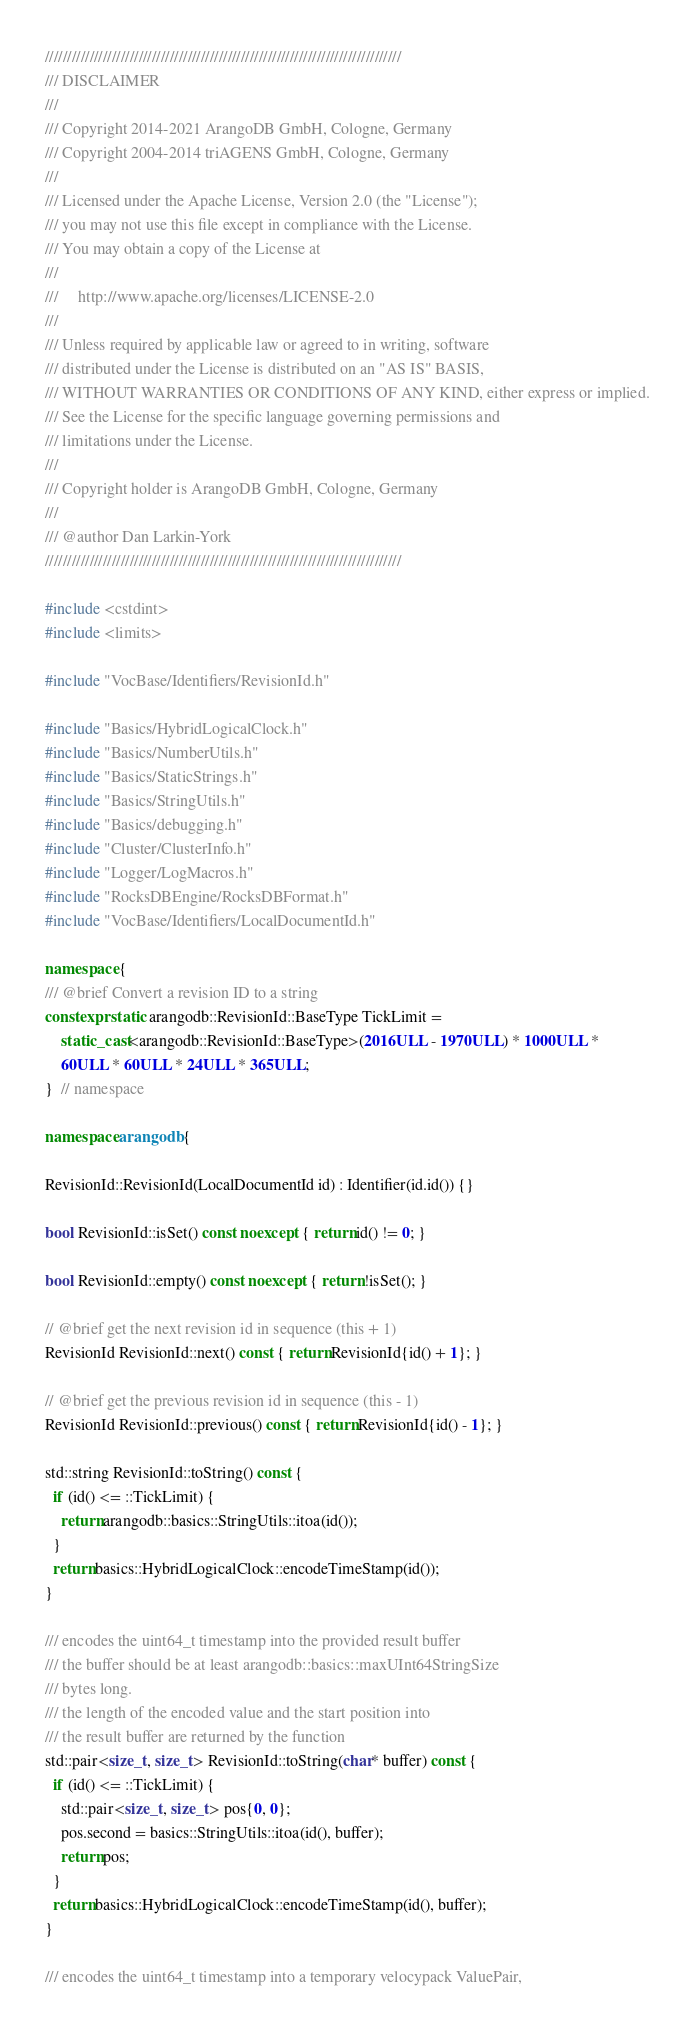<code> <loc_0><loc_0><loc_500><loc_500><_C++_>////////////////////////////////////////////////////////////////////////////////
/// DISCLAIMER
///
/// Copyright 2014-2021 ArangoDB GmbH, Cologne, Germany
/// Copyright 2004-2014 triAGENS GmbH, Cologne, Germany
///
/// Licensed under the Apache License, Version 2.0 (the "License");
/// you may not use this file except in compliance with the License.
/// You may obtain a copy of the License at
///
///     http://www.apache.org/licenses/LICENSE-2.0
///
/// Unless required by applicable law or agreed to in writing, software
/// distributed under the License is distributed on an "AS IS" BASIS,
/// WITHOUT WARRANTIES OR CONDITIONS OF ANY KIND, either express or implied.
/// See the License for the specific language governing permissions and
/// limitations under the License.
///
/// Copyright holder is ArangoDB GmbH, Cologne, Germany
///
/// @author Dan Larkin-York
////////////////////////////////////////////////////////////////////////////////

#include <cstdint>
#include <limits>

#include "VocBase/Identifiers/RevisionId.h"

#include "Basics/HybridLogicalClock.h"
#include "Basics/NumberUtils.h"
#include "Basics/StaticStrings.h"
#include "Basics/StringUtils.h"
#include "Basics/debugging.h"
#include "Cluster/ClusterInfo.h"
#include "Logger/LogMacros.h"
#include "RocksDBEngine/RocksDBFormat.h"
#include "VocBase/Identifiers/LocalDocumentId.h"

namespace {
/// @brief Convert a revision ID to a string
constexpr static arangodb::RevisionId::BaseType TickLimit =
    static_cast<arangodb::RevisionId::BaseType>(2016ULL - 1970ULL) * 1000ULL *
    60ULL * 60ULL * 24ULL * 365ULL;
}  // namespace

namespace arangodb {

RevisionId::RevisionId(LocalDocumentId id) : Identifier(id.id()) {}

bool RevisionId::isSet() const noexcept { return id() != 0; }

bool RevisionId::empty() const noexcept { return !isSet(); }

// @brief get the next revision id in sequence (this + 1)
RevisionId RevisionId::next() const { return RevisionId{id() + 1}; }

// @brief get the previous revision id in sequence (this - 1)
RevisionId RevisionId::previous() const { return RevisionId{id() - 1}; }

std::string RevisionId::toString() const {
  if (id() <= ::TickLimit) {
    return arangodb::basics::StringUtils::itoa(id());
  }
  return basics::HybridLogicalClock::encodeTimeStamp(id());
}

/// encodes the uint64_t timestamp into the provided result buffer
/// the buffer should be at least arangodb::basics::maxUInt64StringSize
/// bytes long.
/// the length of the encoded value and the start position into
/// the result buffer are returned by the function
std::pair<size_t, size_t> RevisionId::toString(char* buffer) const {
  if (id() <= ::TickLimit) {
    std::pair<size_t, size_t> pos{0, 0};
    pos.second = basics::StringUtils::itoa(id(), buffer);
    return pos;
  }
  return basics::HybridLogicalClock::encodeTimeStamp(id(), buffer);
}

/// encodes the uint64_t timestamp into a temporary velocypack ValuePair,</code> 